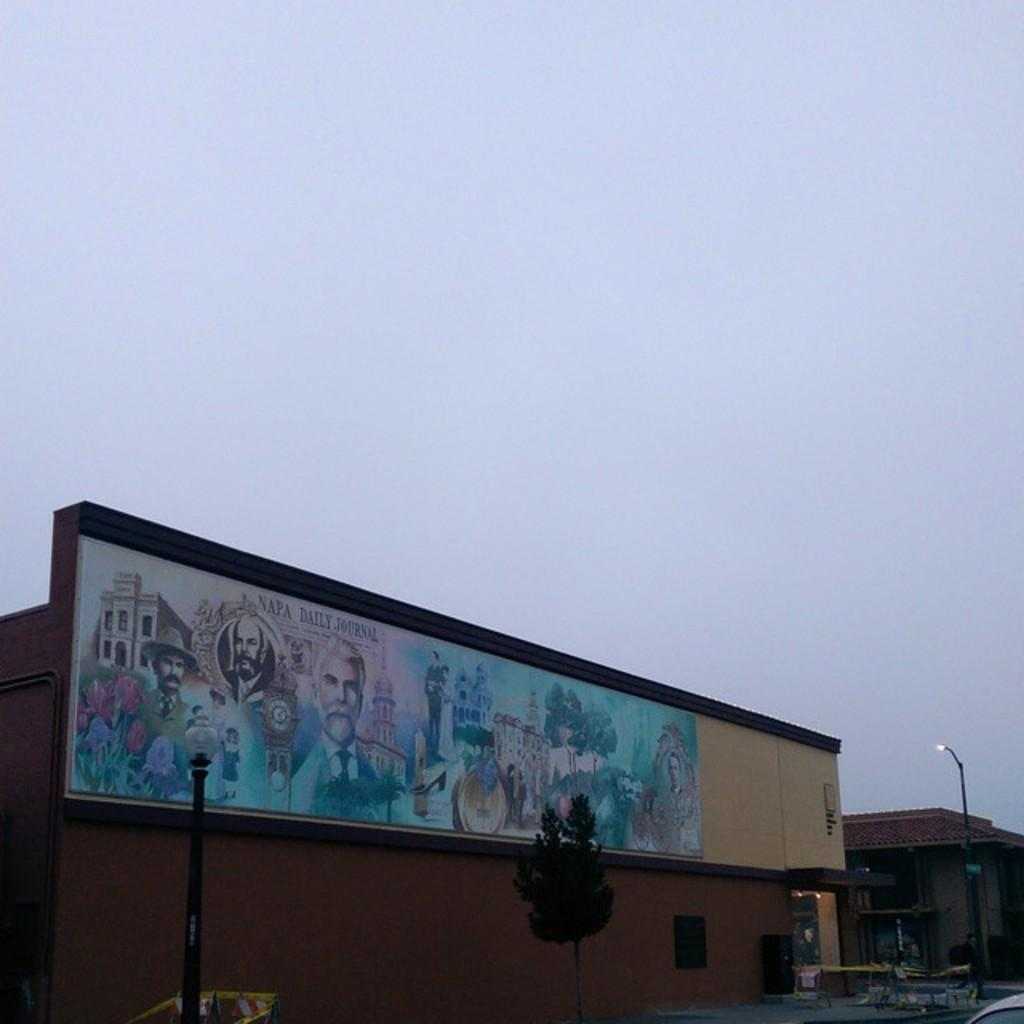<image>
Write a terse but informative summary of the picture. A billboard advertises the Napa Daily Journal with a mural. 